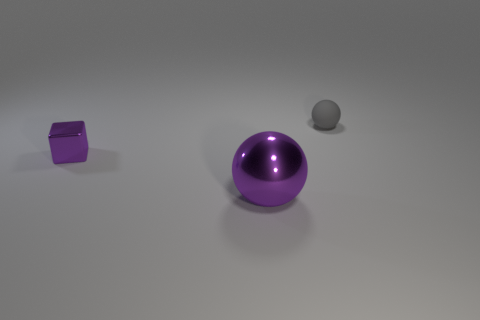There is a sphere that is in front of the gray rubber sphere; does it have the same size as the tiny purple cube?
Your response must be concise. No. There is a ball left of the rubber ball; what is its size?
Provide a short and direct response. Large. Are there any other things that have the same material as the tiny gray thing?
Your answer should be very brief. No. How many small rubber objects are there?
Keep it short and to the point. 1. Do the large metal sphere and the metal block have the same color?
Offer a very short reply. Yes. There is a thing that is both on the left side of the tiny rubber object and behind the big purple ball; what is its color?
Your answer should be compact. Purple. Are there any purple metallic spheres left of the purple block?
Offer a terse response. No. There is a purple metal object that is in front of the purple block; how many matte balls are in front of it?
Provide a short and direct response. 0. There is another purple thing that is the same material as the big object; what size is it?
Offer a terse response. Small. How big is the metallic sphere?
Your answer should be compact. Large. 